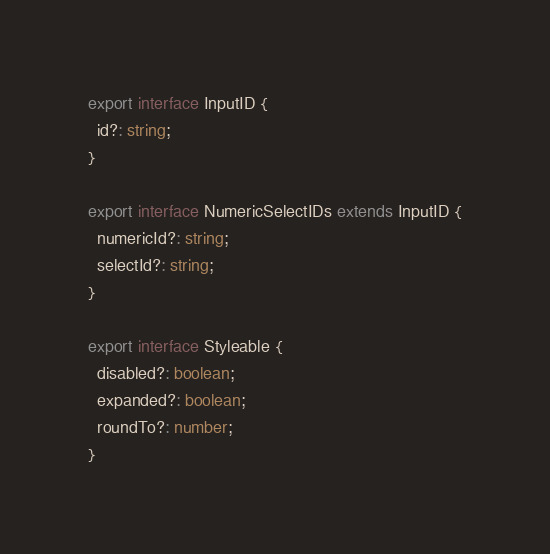<code> <loc_0><loc_0><loc_500><loc_500><_TypeScript_>export interface InputID {
  id?: string;
}

export interface NumericSelectIDs extends InputID {
  numericId?: string;
  selectId?: string;
}

export interface Styleable {
  disabled?: boolean;
  expanded?: boolean;
  roundTo?: number;
}
</code> 